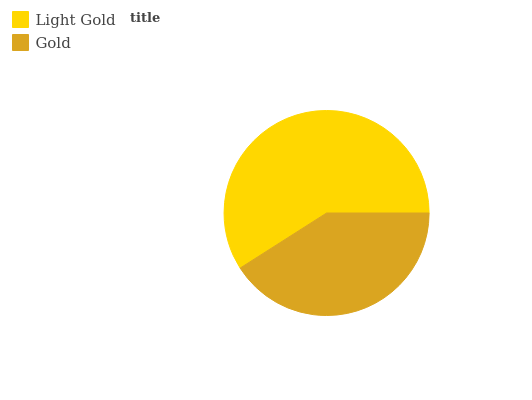Is Gold the minimum?
Answer yes or no. Yes. Is Light Gold the maximum?
Answer yes or no. Yes. Is Gold the maximum?
Answer yes or no. No. Is Light Gold greater than Gold?
Answer yes or no. Yes. Is Gold less than Light Gold?
Answer yes or no. Yes. Is Gold greater than Light Gold?
Answer yes or no. No. Is Light Gold less than Gold?
Answer yes or no. No. Is Light Gold the high median?
Answer yes or no. Yes. Is Gold the low median?
Answer yes or no. Yes. Is Gold the high median?
Answer yes or no. No. Is Light Gold the low median?
Answer yes or no. No. 